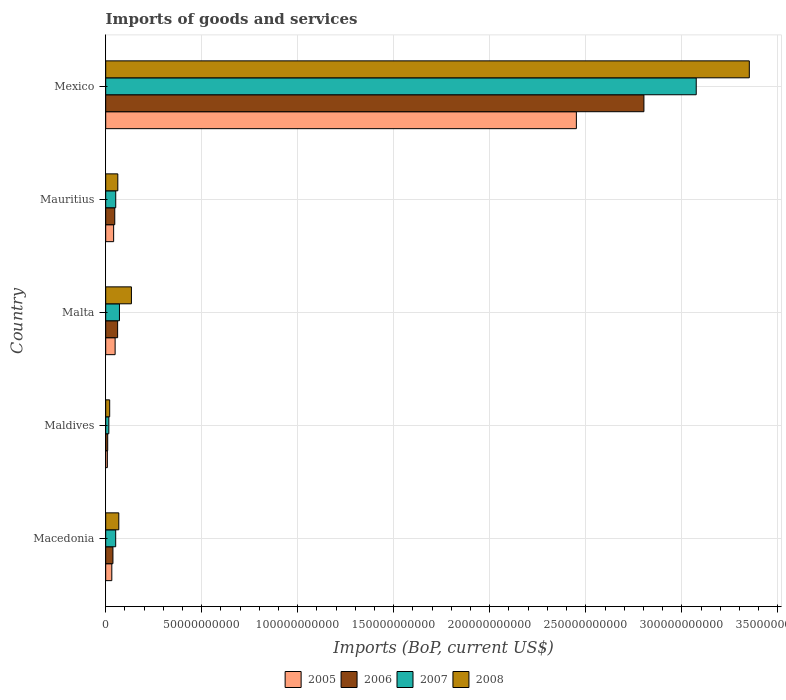How many different coloured bars are there?
Ensure brevity in your answer.  4. Are the number of bars on each tick of the Y-axis equal?
Offer a very short reply. Yes. How many bars are there on the 5th tick from the top?
Give a very brief answer. 4. What is the label of the 4th group of bars from the top?
Provide a succinct answer. Maldives. In how many cases, is the number of bars for a given country not equal to the number of legend labels?
Offer a terse response. 0. What is the amount spent on imports in 2006 in Malta?
Give a very brief answer. 6.21e+09. Across all countries, what is the maximum amount spent on imports in 2007?
Make the answer very short. 3.08e+11. Across all countries, what is the minimum amount spent on imports in 2005?
Offer a terse response. 8.69e+08. In which country was the amount spent on imports in 2006 minimum?
Offer a terse response. Maldives. What is the total amount spent on imports in 2006 in the graph?
Your answer should be very brief. 2.96e+11. What is the difference between the amount spent on imports in 2005 in Malta and that in Mauritius?
Ensure brevity in your answer.  7.79e+08. What is the difference between the amount spent on imports in 2006 in Mexico and the amount spent on imports in 2005 in Malta?
Provide a short and direct response. 2.75e+11. What is the average amount spent on imports in 2007 per country?
Offer a very short reply. 6.53e+1. What is the difference between the amount spent on imports in 2008 and amount spent on imports in 2005 in Maldives?
Your answer should be very brief. 1.21e+09. In how many countries, is the amount spent on imports in 2007 greater than 10000000000 US$?
Provide a succinct answer. 1. What is the ratio of the amount spent on imports in 2007 in Mauritius to that in Mexico?
Provide a succinct answer. 0.02. What is the difference between the highest and the second highest amount spent on imports in 2007?
Your answer should be very brief. 3.00e+11. What is the difference between the highest and the lowest amount spent on imports in 2007?
Offer a very short reply. 3.06e+11. In how many countries, is the amount spent on imports in 2005 greater than the average amount spent on imports in 2005 taken over all countries?
Make the answer very short. 1. Is the sum of the amount spent on imports in 2008 in Mauritius and Mexico greater than the maximum amount spent on imports in 2006 across all countries?
Give a very brief answer. Yes. What does the 2nd bar from the top in Maldives represents?
Your response must be concise. 2007. What does the 2nd bar from the bottom in Mauritius represents?
Ensure brevity in your answer.  2006. Is it the case that in every country, the sum of the amount spent on imports in 2007 and amount spent on imports in 2006 is greater than the amount spent on imports in 2008?
Your answer should be very brief. No. How many bars are there?
Make the answer very short. 20. Are all the bars in the graph horizontal?
Offer a terse response. Yes. How many countries are there in the graph?
Your answer should be compact. 5. What is the difference between two consecutive major ticks on the X-axis?
Your response must be concise. 5.00e+1. Does the graph contain any zero values?
Give a very brief answer. No. Does the graph contain grids?
Keep it short and to the point. Yes. How many legend labels are there?
Your answer should be compact. 4. What is the title of the graph?
Make the answer very short. Imports of goods and services. Does "1967" appear as one of the legend labels in the graph?
Your response must be concise. No. What is the label or title of the X-axis?
Provide a succinct answer. Imports (BoP, current US$). What is the Imports (BoP, current US$) in 2005 in Macedonia?
Your response must be concise. 3.19e+09. What is the Imports (BoP, current US$) of 2006 in Macedonia?
Offer a terse response. 3.77e+09. What is the Imports (BoP, current US$) of 2007 in Macedonia?
Provide a short and direct response. 5.20e+09. What is the Imports (BoP, current US$) of 2008 in Macedonia?
Your response must be concise. 6.82e+09. What is the Imports (BoP, current US$) of 2005 in Maldives?
Offer a very short reply. 8.69e+08. What is the Imports (BoP, current US$) of 2006 in Maldives?
Give a very brief answer. 1.05e+09. What is the Imports (BoP, current US$) in 2007 in Maldives?
Your answer should be compact. 1.64e+09. What is the Imports (BoP, current US$) of 2008 in Maldives?
Your answer should be very brief. 2.08e+09. What is the Imports (BoP, current US$) in 2005 in Malta?
Your response must be concise. 4.91e+09. What is the Imports (BoP, current US$) in 2006 in Malta?
Provide a short and direct response. 6.21e+09. What is the Imports (BoP, current US$) of 2007 in Malta?
Your answer should be compact. 7.16e+09. What is the Imports (BoP, current US$) of 2008 in Malta?
Offer a terse response. 1.34e+1. What is the Imports (BoP, current US$) in 2005 in Mauritius?
Keep it short and to the point. 4.13e+09. What is the Imports (BoP, current US$) of 2006 in Mauritius?
Your answer should be very brief. 4.73e+09. What is the Imports (BoP, current US$) in 2007 in Mauritius?
Your answer should be very brief. 5.23e+09. What is the Imports (BoP, current US$) in 2008 in Mauritius?
Offer a terse response. 6.31e+09. What is the Imports (BoP, current US$) in 2005 in Mexico?
Your answer should be very brief. 2.45e+11. What is the Imports (BoP, current US$) in 2006 in Mexico?
Your answer should be compact. 2.80e+11. What is the Imports (BoP, current US$) in 2007 in Mexico?
Give a very brief answer. 3.08e+11. What is the Imports (BoP, current US$) in 2008 in Mexico?
Offer a terse response. 3.35e+11. Across all countries, what is the maximum Imports (BoP, current US$) in 2005?
Provide a succinct answer. 2.45e+11. Across all countries, what is the maximum Imports (BoP, current US$) in 2006?
Your answer should be very brief. 2.80e+11. Across all countries, what is the maximum Imports (BoP, current US$) of 2007?
Your answer should be compact. 3.08e+11. Across all countries, what is the maximum Imports (BoP, current US$) of 2008?
Make the answer very short. 3.35e+11. Across all countries, what is the minimum Imports (BoP, current US$) in 2005?
Your answer should be compact. 8.69e+08. Across all countries, what is the minimum Imports (BoP, current US$) in 2006?
Keep it short and to the point. 1.05e+09. Across all countries, what is the minimum Imports (BoP, current US$) of 2007?
Your answer should be compact. 1.64e+09. Across all countries, what is the minimum Imports (BoP, current US$) of 2008?
Your answer should be compact. 2.08e+09. What is the total Imports (BoP, current US$) of 2005 in the graph?
Your answer should be very brief. 2.58e+11. What is the total Imports (BoP, current US$) of 2006 in the graph?
Keep it short and to the point. 2.96e+11. What is the total Imports (BoP, current US$) in 2007 in the graph?
Offer a terse response. 3.27e+11. What is the total Imports (BoP, current US$) of 2008 in the graph?
Provide a short and direct response. 3.64e+11. What is the difference between the Imports (BoP, current US$) in 2005 in Macedonia and that in Maldives?
Your answer should be compact. 2.32e+09. What is the difference between the Imports (BoP, current US$) in 2006 in Macedonia and that in Maldives?
Offer a terse response. 2.73e+09. What is the difference between the Imports (BoP, current US$) in 2007 in Macedonia and that in Maldives?
Your answer should be very brief. 3.56e+09. What is the difference between the Imports (BoP, current US$) of 2008 in Macedonia and that in Maldives?
Give a very brief answer. 4.74e+09. What is the difference between the Imports (BoP, current US$) of 2005 in Macedonia and that in Malta?
Make the answer very short. -1.72e+09. What is the difference between the Imports (BoP, current US$) of 2006 in Macedonia and that in Malta?
Your response must be concise. -2.44e+09. What is the difference between the Imports (BoP, current US$) in 2007 in Macedonia and that in Malta?
Provide a short and direct response. -1.96e+09. What is the difference between the Imports (BoP, current US$) in 2008 in Macedonia and that in Malta?
Your answer should be compact. -6.58e+09. What is the difference between the Imports (BoP, current US$) in 2005 in Macedonia and that in Mauritius?
Your answer should be very brief. -9.46e+08. What is the difference between the Imports (BoP, current US$) of 2006 in Macedonia and that in Mauritius?
Provide a short and direct response. -9.53e+08. What is the difference between the Imports (BoP, current US$) in 2007 in Macedonia and that in Mauritius?
Ensure brevity in your answer.  -2.49e+07. What is the difference between the Imports (BoP, current US$) of 2008 in Macedonia and that in Mauritius?
Offer a terse response. 5.14e+08. What is the difference between the Imports (BoP, current US$) in 2005 in Macedonia and that in Mexico?
Offer a very short reply. -2.42e+11. What is the difference between the Imports (BoP, current US$) of 2006 in Macedonia and that in Mexico?
Give a very brief answer. -2.76e+11. What is the difference between the Imports (BoP, current US$) in 2007 in Macedonia and that in Mexico?
Make the answer very short. -3.02e+11. What is the difference between the Imports (BoP, current US$) in 2008 in Macedonia and that in Mexico?
Keep it short and to the point. -3.28e+11. What is the difference between the Imports (BoP, current US$) in 2005 in Maldives and that in Malta?
Your answer should be compact. -4.04e+09. What is the difference between the Imports (BoP, current US$) in 2006 in Maldives and that in Malta?
Provide a short and direct response. -5.16e+09. What is the difference between the Imports (BoP, current US$) in 2007 in Maldives and that in Malta?
Provide a short and direct response. -5.53e+09. What is the difference between the Imports (BoP, current US$) of 2008 in Maldives and that in Malta?
Your answer should be very brief. -1.13e+1. What is the difference between the Imports (BoP, current US$) in 2005 in Maldives and that in Mauritius?
Provide a succinct answer. -3.26e+09. What is the difference between the Imports (BoP, current US$) of 2006 in Maldives and that in Mauritius?
Provide a succinct answer. -3.68e+09. What is the difference between the Imports (BoP, current US$) in 2007 in Maldives and that in Mauritius?
Keep it short and to the point. -3.59e+09. What is the difference between the Imports (BoP, current US$) in 2008 in Maldives and that in Mauritius?
Make the answer very short. -4.23e+09. What is the difference between the Imports (BoP, current US$) of 2005 in Maldives and that in Mexico?
Your answer should be compact. -2.44e+11. What is the difference between the Imports (BoP, current US$) in 2006 in Maldives and that in Mexico?
Your answer should be very brief. -2.79e+11. What is the difference between the Imports (BoP, current US$) in 2007 in Maldives and that in Mexico?
Your response must be concise. -3.06e+11. What is the difference between the Imports (BoP, current US$) of 2008 in Maldives and that in Mexico?
Your response must be concise. -3.33e+11. What is the difference between the Imports (BoP, current US$) in 2005 in Malta and that in Mauritius?
Your answer should be very brief. 7.79e+08. What is the difference between the Imports (BoP, current US$) of 2006 in Malta and that in Mauritius?
Your answer should be very brief. 1.48e+09. What is the difference between the Imports (BoP, current US$) of 2007 in Malta and that in Mauritius?
Keep it short and to the point. 1.94e+09. What is the difference between the Imports (BoP, current US$) in 2008 in Malta and that in Mauritius?
Your response must be concise. 7.09e+09. What is the difference between the Imports (BoP, current US$) of 2005 in Malta and that in Mexico?
Offer a terse response. -2.40e+11. What is the difference between the Imports (BoP, current US$) in 2006 in Malta and that in Mexico?
Provide a succinct answer. -2.74e+11. What is the difference between the Imports (BoP, current US$) in 2007 in Malta and that in Mexico?
Make the answer very short. -3.00e+11. What is the difference between the Imports (BoP, current US$) in 2008 in Malta and that in Mexico?
Offer a terse response. -3.22e+11. What is the difference between the Imports (BoP, current US$) in 2005 in Mauritius and that in Mexico?
Offer a very short reply. -2.41e+11. What is the difference between the Imports (BoP, current US$) of 2006 in Mauritius and that in Mexico?
Give a very brief answer. -2.76e+11. What is the difference between the Imports (BoP, current US$) of 2007 in Mauritius and that in Mexico?
Make the answer very short. -3.02e+11. What is the difference between the Imports (BoP, current US$) of 2008 in Mauritius and that in Mexico?
Your answer should be compact. -3.29e+11. What is the difference between the Imports (BoP, current US$) in 2005 in Macedonia and the Imports (BoP, current US$) in 2006 in Maldives?
Keep it short and to the point. 2.14e+09. What is the difference between the Imports (BoP, current US$) in 2005 in Macedonia and the Imports (BoP, current US$) in 2007 in Maldives?
Provide a succinct answer. 1.55e+09. What is the difference between the Imports (BoP, current US$) of 2005 in Macedonia and the Imports (BoP, current US$) of 2008 in Maldives?
Give a very brief answer. 1.11e+09. What is the difference between the Imports (BoP, current US$) of 2006 in Macedonia and the Imports (BoP, current US$) of 2007 in Maldives?
Ensure brevity in your answer.  2.14e+09. What is the difference between the Imports (BoP, current US$) of 2006 in Macedonia and the Imports (BoP, current US$) of 2008 in Maldives?
Ensure brevity in your answer.  1.70e+09. What is the difference between the Imports (BoP, current US$) of 2007 in Macedonia and the Imports (BoP, current US$) of 2008 in Maldives?
Offer a very short reply. 3.12e+09. What is the difference between the Imports (BoP, current US$) in 2005 in Macedonia and the Imports (BoP, current US$) in 2006 in Malta?
Give a very brief answer. -3.02e+09. What is the difference between the Imports (BoP, current US$) in 2005 in Macedonia and the Imports (BoP, current US$) in 2007 in Malta?
Your answer should be compact. -3.97e+09. What is the difference between the Imports (BoP, current US$) of 2005 in Macedonia and the Imports (BoP, current US$) of 2008 in Malta?
Your answer should be compact. -1.02e+1. What is the difference between the Imports (BoP, current US$) of 2006 in Macedonia and the Imports (BoP, current US$) of 2007 in Malta?
Offer a very short reply. -3.39e+09. What is the difference between the Imports (BoP, current US$) in 2006 in Macedonia and the Imports (BoP, current US$) in 2008 in Malta?
Offer a terse response. -9.63e+09. What is the difference between the Imports (BoP, current US$) in 2007 in Macedonia and the Imports (BoP, current US$) in 2008 in Malta?
Your response must be concise. -8.20e+09. What is the difference between the Imports (BoP, current US$) in 2005 in Macedonia and the Imports (BoP, current US$) in 2006 in Mauritius?
Ensure brevity in your answer.  -1.54e+09. What is the difference between the Imports (BoP, current US$) in 2005 in Macedonia and the Imports (BoP, current US$) in 2007 in Mauritius?
Give a very brief answer. -2.04e+09. What is the difference between the Imports (BoP, current US$) of 2005 in Macedonia and the Imports (BoP, current US$) of 2008 in Mauritius?
Your answer should be compact. -3.12e+09. What is the difference between the Imports (BoP, current US$) in 2006 in Macedonia and the Imports (BoP, current US$) in 2007 in Mauritius?
Your response must be concise. -1.45e+09. What is the difference between the Imports (BoP, current US$) in 2006 in Macedonia and the Imports (BoP, current US$) in 2008 in Mauritius?
Ensure brevity in your answer.  -2.53e+09. What is the difference between the Imports (BoP, current US$) of 2007 in Macedonia and the Imports (BoP, current US$) of 2008 in Mauritius?
Ensure brevity in your answer.  -1.11e+09. What is the difference between the Imports (BoP, current US$) of 2005 in Macedonia and the Imports (BoP, current US$) of 2006 in Mexico?
Make the answer very short. -2.77e+11. What is the difference between the Imports (BoP, current US$) in 2005 in Macedonia and the Imports (BoP, current US$) in 2007 in Mexico?
Make the answer very short. -3.04e+11. What is the difference between the Imports (BoP, current US$) in 2005 in Macedonia and the Imports (BoP, current US$) in 2008 in Mexico?
Provide a succinct answer. -3.32e+11. What is the difference between the Imports (BoP, current US$) of 2006 in Macedonia and the Imports (BoP, current US$) of 2007 in Mexico?
Offer a very short reply. -3.04e+11. What is the difference between the Imports (BoP, current US$) in 2006 in Macedonia and the Imports (BoP, current US$) in 2008 in Mexico?
Keep it short and to the point. -3.31e+11. What is the difference between the Imports (BoP, current US$) of 2007 in Macedonia and the Imports (BoP, current US$) of 2008 in Mexico?
Give a very brief answer. -3.30e+11. What is the difference between the Imports (BoP, current US$) in 2005 in Maldives and the Imports (BoP, current US$) in 2006 in Malta?
Offer a very short reply. -5.34e+09. What is the difference between the Imports (BoP, current US$) in 2005 in Maldives and the Imports (BoP, current US$) in 2007 in Malta?
Provide a short and direct response. -6.29e+09. What is the difference between the Imports (BoP, current US$) in 2005 in Maldives and the Imports (BoP, current US$) in 2008 in Malta?
Ensure brevity in your answer.  -1.25e+1. What is the difference between the Imports (BoP, current US$) of 2006 in Maldives and the Imports (BoP, current US$) of 2007 in Malta?
Your answer should be compact. -6.12e+09. What is the difference between the Imports (BoP, current US$) of 2006 in Maldives and the Imports (BoP, current US$) of 2008 in Malta?
Offer a terse response. -1.24e+1. What is the difference between the Imports (BoP, current US$) in 2007 in Maldives and the Imports (BoP, current US$) in 2008 in Malta?
Keep it short and to the point. -1.18e+1. What is the difference between the Imports (BoP, current US$) in 2005 in Maldives and the Imports (BoP, current US$) in 2006 in Mauritius?
Offer a very short reply. -3.86e+09. What is the difference between the Imports (BoP, current US$) of 2005 in Maldives and the Imports (BoP, current US$) of 2007 in Mauritius?
Your response must be concise. -4.36e+09. What is the difference between the Imports (BoP, current US$) of 2005 in Maldives and the Imports (BoP, current US$) of 2008 in Mauritius?
Offer a terse response. -5.44e+09. What is the difference between the Imports (BoP, current US$) of 2006 in Maldives and the Imports (BoP, current US$) of 2007 in Mauritius?
Your answer should be compact. -4.18e+09. What is the difference between the Imports (BoP, current US$) of 2006 in Maldives and the Imports (BoP, current US$) of 2008 in Mauritius?
Offer a terse response. -5.26e+09. What is the difference between the Imports (BoP, current US$) in 2007 in Maldives and the Imports (BoP, current US$) in 2008 in Mauritius?
Your answer should be very brief. -4.67e+09. What is the difference between the Imports (BoP, current US$) of 2005 in Maldives and the Imports (BoP, current US$) of 2006 in Mexico?
Your response must be concise. -2.79e+11. What is the difference between the Imports (BoP, current US$) in 2005 in Maldives and the Imports (BoP, current US$) in 2007 in Mexico?
Make the answer very short. -3.07e+11. What is the difference between the Imports (BoP, current US$) in 2005 in Maldives and the Imports (BoP, current US$) in 2008 in Mexico?
Offer a very short reply. -3.34e+11. What is the difference between the Imports (BoP, current US$) of 2006 in Maldives and the Imports (BoP, current US$) of 2007 in Mexico?
Provide a succinct answer. -3.06e+11. What is the difference between the Imports (BoP, current US$) in 2006 in Maldives and the Imports (BoP, current US$) in 2008 in Mexico?
Keep it short and to the point. -3.34e+11. What is the difference between the Imports (BoP, current US$) of 2007 in Maldives and the Imports (BoP, current US$) of 2008 in Mexico?
Offer a very short reply. -3.34e+11. What is the difference between the Imports (BoP, current US$) in 2005 in Malta and the Imports (BoP, current US$) in 2006 in Mauritius?
Your response must be concise. 1.87e+08. What is the difference between the Imports (BoP, current US$) in 2005 in Malta and the Imports (BoP, current US$) in 2007 in Mauritius?
Provide a short and direct response. -3.13e+08. What is the difference between the Imports (BoP, current US$) in 2005 in Malta and the Imports (BoP, current US$) in 2008 in Mauritius?
Keep it short and to the point. -1.39e+09. What is the difference between the Imports (BoP, current US$) in 2006 in Malta and the Imports (BoP, current US$) in 2007 in Mauritius?
Offer a very short reply. 9.85e+08. What is the difference between the Imports (BoP, current US$) of 2006 in Malta and the Imports (BoP, current US$) of 2008 in Mauritius?
Your answer should be very brief. -9.55e+07. What is the difference between the Imports (BoP, current US$) of 2007 in Malta and the Imports (BoP, current US$) of 2008 in Mauritius?
Ensure brevity in your answer.  8.56e+08. What is the difference between the Imports (BoP, current US$) of 2005 in Malta and the Imports (BoP, current US$) of 2006 in Mexico?
Keep it short and to the point. -2.75e+11. What is the difference between the Imports (BoP, current US$) of 2005 in Malta and the Imports (BoP, current US$) of 2007 in Mexico?
Your answer should be very brief. -3.03e+11. What is the difference between the Imports (BoP, current US$) in 2005 in Malta and the Imports (BoP, current US$) in 2008 in Mexico?
Your response must be concise. -3.30e+11. What is the difference between the Imports (BoP, current US$) in 2006 in Malta and the Imports (BoP, current US$) in 2007 in Mexico?
Provide a short and direct response. -3.01e+11. What is the difference between the Imports (BoP, current US$) in 2006 in Malta and the Imports (BoP, current US$) in 2008 in Mexico?
Your response must be concise. -3.29e+11. What is the difference between the Imports (BoP, current US$) in 2007 in Malta and the Imports (BoP, current US$) in 2008 in Mexico?
Make the answer very short. -3.28e+11. What is the difference between the Imports (BoP, current US$) in 2005 in Mauritius and the Imports (BoP, current US$) in 2006 in Mexico?
Provide a short and direct response. -2.76e+11. What is the difference between the Imports (BoP, current US$) in 2005 in Mauritius and the Imports (BoP, current US$) in 2007 in Mexico?
Offer a very short reply. -3.03e+11. What is the difference between the Imports (BoP, current US$) in 2005 in Mauritius and the Imports (BoP, current US$) in 2008 in Mexico?
Make the answer very short. -3.31e+11. What is the difference between the Imports (BoP, current US$) of 2006 in Mauritius and the Imports (BoP, current US$) of 2007 in Mexico?
Provide a short and direct response. -3.03e+11. What is the difference between the Imports (BoP, current US$) of 2006 in Mauritius and the Imports (BoP, current US$) of 2008 in Mexico?
Give a very brief answer. -3.30e+11. What is the difference between the Imports (BoP, current US$) of 2007 in Mauritius and the Imports (BoP, current US$) of 2008 in Mexico?
Provide a short and direct response. -3.30e+11. What is the average Imports (BoP, current US$) in 2005 per country?
Offer a terse response. 5.16e+1. What is the average Imports (BoP, current US$) of 2006 per country?
Your answer should be very brief. 5.92e+1. What is the average Imports (BoP, current US$) in 2007 per country?
Offer a terse response. 6.53e+1. What is the average Imports (BoP, current US$) of 2008 per country?
Provide a succinct answer. 7.28e+1. What is the difference between the Imports (BoP, current US$) of 2005 and Imports (BoP, current US$) of 2006 in Macedonia?
Your answer should be compact. -5.85e+08. What is the difference between the Imports (BoP, current US$) of 2005 and Imports (BoP, current US$) of 2007 in Macedonia?
Ensure brevity in your answer.  -2.01e+09. What is the difference between the Imports (BoP, current US$) of 2005 and Imports (BoP, current US$) of 2008 in Macedonia?
Provide a succinct answer. -3.63e+09. What is the difference between the Imports (BoP, current US$) of 2006 and Imports (BoP, current US$) of 2007 in Macedonia?
Provide a short and direct response. -1.43e+09. What is the difference between the Imports (BoP, current US$) in 2006 and Imports (BoP, current US$) in 2008 in Macedonia?
Give a very brief answer. -3.05e+09. What is the difference between the Imports (BoP, current US$) of 2007 and Imports (BoP, current US$) of 2008 in Macedonia?
Ensure brevity in your answer.  -1.62e+09. What is the difference between the Imports (BoP, current US$) of 2005 and Imports (BoP, current US$) of 2006 in Maldives?
Your answer should be compact. -1.78e+08. What is the difference between the Imports (BoP, current US$) in 2005 and Imports (BoP, current US$) in 2007 in Maldives?
Your response must be concise. -7.67e+08. What is the difference between the Imports (BoP, current US$) of 2005 and Imports (BoP, current US$) of 2008 in Maldives?
Ensure brevity in your answer.  -1.21e+09. What is the difference between the Imports (BoP, current US$) in 2006 and Imports (BoP, current US$) in 2007 in Maldives?
Offer a terse response. -5.89e+08. What is the difference between the Imports (BoP, current US$) of 2006 and Imports (BoP, current US$) of 2008 in Maldives?
Your response must be concise. -1.03e+09. What is the difference between the Imports (BoP, current US$) of 2007 and Imports (BoP, current US$) of 2008 in Maldives?
Your answer should be very brief. -4.41e+08. What is the difference between the Imports (BoP, current US$) in 2005 and Imports (BoP, current US$) in 2006 in Malta?
Offer a terse response. -1.30e+09. What is the difference between the Imports (BoP, current US$) in 2005 and Imports (BoP, current US$) in 2007 in Malta?
Your answer should be very brief. -2.25e+09. What is the difference between the Imports (BoP, current US$) of 2005 and Imports (BoP, current US$) of 2008 in Malta?
Give a very brief answer. -8.49e+09. What is the difference between the Imports (BoP, current US$) in 2006 and Imports (BoP, current US$) in 2007 in Malta?
Your answer should be compact. -9.52e+08. What is the difference between the Imports (BoP, current US$) in 2006 and Imports (BoP, current US$) in 2008 in Malta?
Your response must be concise. -7.19e+09. What is the difference between the Imports (BoP, current US$) in 2007 and Imports (BoP, current US$) in 2008 in Malta?
Give a very brief answer. -6.24e+09. What is the difference between the Imports (BoP, current US$) of 2005 and Imports (BoP, current US$) of 2006 in Mauritius?
Make the answer very short. -5.93e+08. What is the difference between the Imports (BoP, current US$) in 2005 and Imports (BoP, current US$) in 2007 in Mauritius?
Ensure brevity in your answer.  -1.09e+09. What is the difference between the Imports (BoP, current US$) in 2005 and Imports (BoP, current US$) in 2008 in Mauritius?
Your answer should be very brief. -2.17e+09. What is the difference between the Imports (BoP, current US$) of 2006 and Imports (BoP, current US$) of 2007 in Mauritius?
Ensure brevity in your answer.  -4.99e+08. What is the difference between the Imports (BoP, current US$) of 2006 and Imports (BoP, current US$) of 2008 in Mauritius?
Your answer should be compact. -1.58e+09. What is the difference between the Imports (BoP, current US$) in 2007 and Imports (BoP, current US$) in 2008 in Mauritius?
Provide a succinct answer. -1.08e+09. What is the difference between the Imports (BoP, current US$) of 2005 and Imports (BoP, current US$) of 2006 in Mexico?
Keep it short and to the point. -3.52e+1. What is the difference between the Imports (BoP, current US$) in 2005 and Imports (BoP, current US$) in 2007 in Mexico?
Your answer should be compact. -6.24e+1. What is the difference between the Imports (BoP, current US$) in 2005 and Imports (BoP, current US$) in 2008 in Mexico?
Offer a terse response. -9.00e+1. What is the difference between the Imports (BoP, current US$) in 2006 and Imports (BoP, current US$) in 2007 in Mexico?
Provide a short and direct response. -2.72e+1. What is the difference between the Imports (BoP, current US$) of 2006 and Imports (BoP, current US$) of 2008 in Mexico?
Offer a terse response. -5.49e+1. What is the difference between the Imports (BoP, current US$) in 2007 and Imports (BoP, current US$) in 2008 in Mexico?
Offer a very short reply. -2.76e+1. What is the ratio of the Imports (BoP, current US$) of 2005 in Macedonia to that in Maldives?
Offer a very short reply. 3.67. What is the ratio of the Imports (BoP, current US$) in 2006 in Macedonia to that in Maldives?
Your answer should be very brief. 3.6. What is the ratio of the Imports (BoP, current US$) in 2007 in Macedonia to that in Maldives?
Provide a short and direct response. 3.18. What is the ratio of the Imports (BoP, current US$) in 2008 in Macedonia to that in Maldives?
Your answer should be compact. 3.28. What is the ratio of the Imports (BoP, current US$) of 2005 in Macedonia to that in Malta?
Make the answer very short. 0.65. What is the ratio of the Imports (BoP, current US$) in 2006 in Macedonia to that in Malta?
Provide a short and direct response. 0.61. What is the ratio of the Imports (BoP, current US$) in 2007 in Macedonia to that in Malta?
Ensure brevity in your answer.  0.73. What is the ratio of the Imports (BoP, current US$) in 2008 in Macedonia to that in Malta?
Make the answer very short. 0.51. What is the ratio of the Imports (BoP, current US$) in 2005 in Macedonia to that in Mauritius?
Your answer should be compact. 0.77. What is the ratio of the Imports (BoP, current US$) of 2006 in Macedonia to that in Mauritius?
Give a very brief answer. 0.8. What is the ratio of the Imports (BoP, current US$) of 2008 in Macedonia to that in Mauritius?
Your answer should be compact. 1.08. What is the ratio of the Imports (BoP, current US$) in 2005 in Macedonia to that in Mexico?
Keep it short and to the point. 0.01. What is the ratio of the Imports (BoP, current US$) of 2006 in Macedonia to that in Mexico?
Ensure brevity in your answer.  0.01. What is the ratio of the Imports (BoP, current US$) in 2007 in Macedonia to that in Mexico?
Keep it short and to the point. 0.02. What is the ratio of the Imports (BoP, current US$) of 2008 in Macedonia to that in Mexico?
Keep it short and to the point. 0.02. What is the ratio of the Imports (BoP, current US$) in 2005 in Maldives to that in Malta?
Offer a very short reply. 0.18. What is the ratio of the Imports (BoP, current US$) in 2006 in Maldives to that in Malta?
Keep it short and to the point. 0.17. What is the ratio of the Imports (BoP, current US$) of 2007 in Maldives to that in Malta?
Give a very brief answer. 0.23. What is the ratio of the Imports (BoP, current US$) in 2008 in Maldives to that in Malta?
Your answer should be very brief. 0.15. What is the ratio of the Imports (BoP, current US$) of 2005 in Maldives to that in Mauritius?
Your response must be concise. 0.21. What is the ratio of the Imports (BoP, current US$) in 2006 in Maldives to that in Mauritius?
Ensure brevity in your answer.  0.22. What is the ratio of the Imports (BoP, current US$) in 2007 in Maldives to that in Mauritius?
Offer a very short reply. 0.31. What is the ratio of the Imports (BoP, current US$) of 2008 in Maldives to that in Mauritius?
Your answer should be compact. 0.33. What is the ratio of the Imports (BoP, current US$) in 2005 in Maldives to that in Mexico?
Provide a succinct answer. 0. What is the ratio of the Imports (BoP, current US$) in 2006 in Maldives to that in Mexico?
Your response must be concise. 0. What is the ratio of the Imports (BoP, current US$) of 2007 in Maldives to that in Mexico?
Offer a terse response. 0.01. What is the ratio of the Imports (BoP, current US$) of 2008 in Maldives to that in Mexico?
Your answer should be compact. 0.01. What is the ratio of the Imports (BoP, current US$) of 2005 in Malta to that in Mauritius?
Offer a very short reply. 1.19. What is the ratio of the Imports (BoP, current US$) in 2006 in Malta to that in Mauritius?
Offer a terse response. 1.31. What is the ratio of the Imports (BoP, current US$) in 2007 in Malta to that in Mauritius?
Give a very brief answer. 1.37. What is the ratio of the Imports (BoP, current US$) of 2008 in Malta to that in Mauritius?
Keep it short and to the point. 2.12. What is the ratio of the Imports (BoP, current US$) in 2006 in Malta to that in Mexico?
Offer a very short reply. 0.02. What is the ratio of the Imports (BoP, current US$) in 2007 in Malta to that in Mexico?
Your answer should be compact. 0.02. What is the ratio of the Imports (BoP, current US$) of 2008 in Malta to that in Mexico?
Your answer should be compact. 0.04. What is the ratio of the Imports (BoP, current US$) of 2005 in Mauritius to that in Mexico?
Your response must be concise. 0.02. What is the ratio of the Imports (BoP, current US$) of 2006 in Mauritius to that in Mexico?
Your answer should be very brief. 0.02. What is the ratio of the Imports (BoP, current US$) of 2007 in Mauritius to that in Mexico?
Keep it short and to the point. 0.02. What is the ratio of the Imports (BoP, current US$) in 2008 in Mauritius to that in Mexico?
Keep it short and to the point. 0.02. What is the difference between the highest and the second highest Imports (BoP, current US$) in 2005?
Your answer should be compact. 2.40e+11. What is the difference between the highest and the second highest Imports (BoP, current US$) in 2006?
Your answer should be very brief. 2.74e+11. What is the difference between the highest and the second highest Imports (BoP, current US$) of 2007?
Offer a terse response. 3.00e+11. What is the difference between the highest and the second highest Imports (BoP, current US$) in 2008?
Give a very brief answer. 3.22e+11. What is the difference between the highest and the lowest Imports (BoP, current US$) in 2005?
Offer a very short reply. 2.44e+11. What is the difference between the highest and the lowest Imports (BoP, current US$) of 2006?
Offer a very short reply. 2.79e+11. What is the difference between the highest and the lowest Imports (BoP, current US$) of 2007?
Your answer should be compact. 3.06e+11. What is the difference between the highest and the lowest Imports (BoP, current US$) in 2008?
Provide a short and direct response. 3.33e+11. 